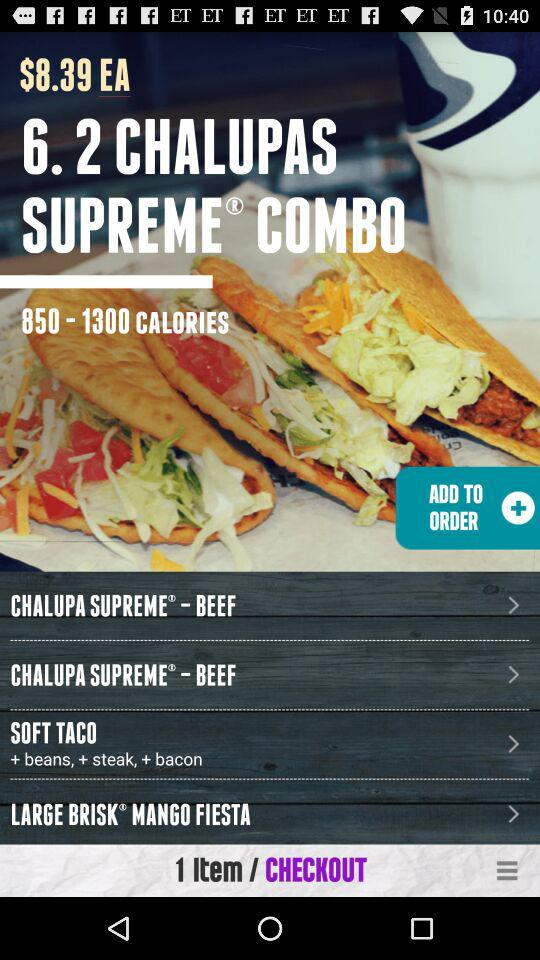How many items are in the cart?
Answer the question using a single word or phrase. 1 